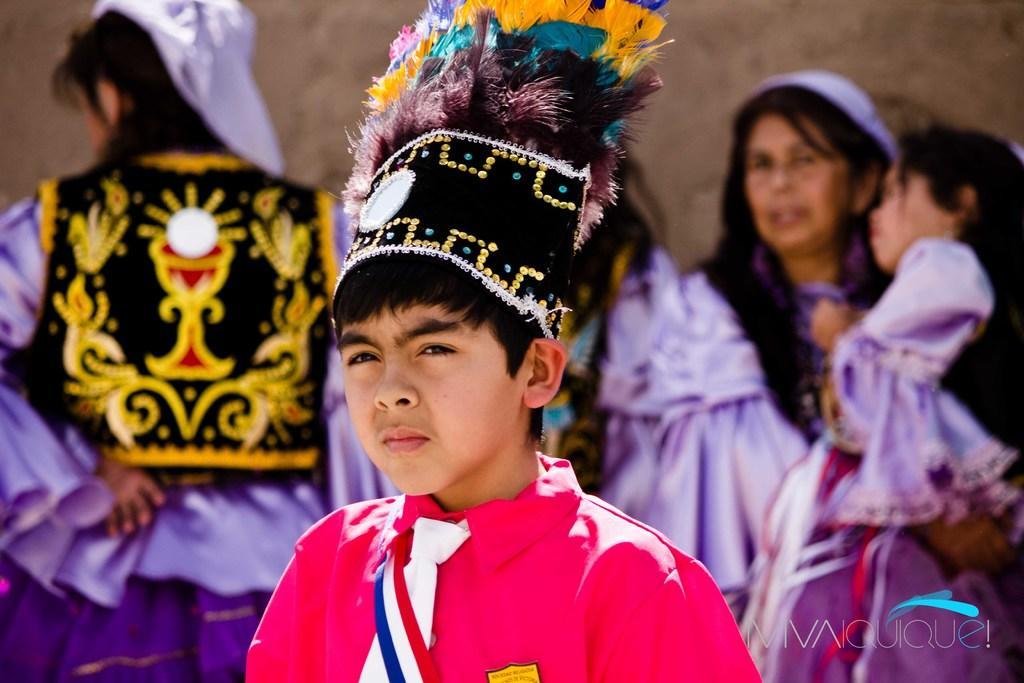Describe this image in one or two sentences. Here people are standing wearing clothes, this is wall. 